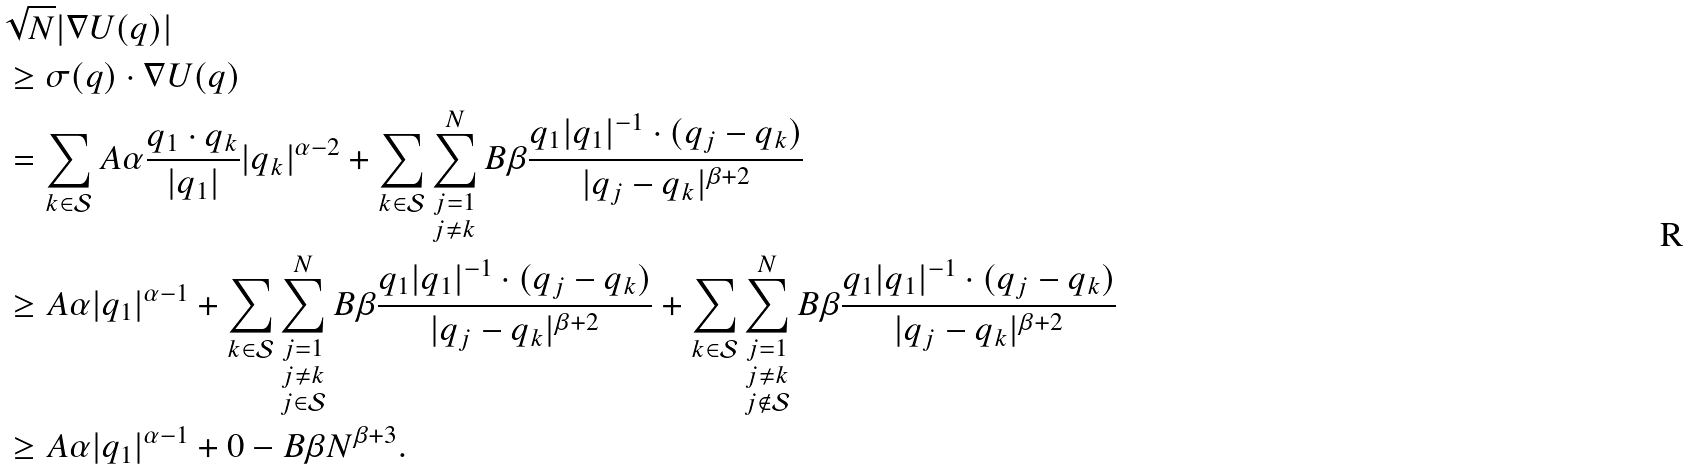<formula> <loc_0><loc_0><loc_500><loc_500>& \sqrt { N } | \nabla U ( q ) | \\ & \geq \sigma ( q ) \cdot \nabla U ( q ) \\ & = \sum _ { k \in \mathcal { S } } A \alpha \frac { q _ { 1 } \cdot q _ { k } } { | q _ { 1 } | } | q _ { k } | ^ { \alpha - 2 } + \sum _ { k \in \mathcal { S } } \sum _ { \substack { j = 1 \\ j \neq k } } ^ { N } B \beta \frac { q _ { 1 } | q _ { 1 } | ^ { - 1 } \cdot ( q _ { j } - q _ { k } ) } { | q _ { j } - q _ { k } | ^ { \beta + 2 } } \\ & \geq A \alpha | q _ { 1 } | ^ { \alpha - 1 } + \sum _ { k \in \mathcal { S } } \sum _ { \substack { j = 1 \\ j \neq k \\ j \in \mathcal { S } } } ^ { N } B \beta \frac { q _ { 1 } | q _ { 1 } | ^ { - 1 } \cdot ( q _ { j } - q _ { k } ) } { | q _ { j } - q _ { k } | ^ { \beta + 2 } } + \sum _ { k \in \mathcal { S } } \sum _ { \substack { j = 1 \\ j \neq k \\ j \notin \mathcal { S } } } ^ { N } B \beta \frac { q _ { 1 } | q _ { 1 } | ^ { - 1 } \cdot ( q _ { j } - q _ { k } ) } { | q _ { j } - q _ { k } | ^ { \beta + 2 } } \\ & \geq A \alpha | q _ { 1 } | ^ { \alpha - 1 } + 0 - B \beta N ^ { \beta + 3 } .</formula> 